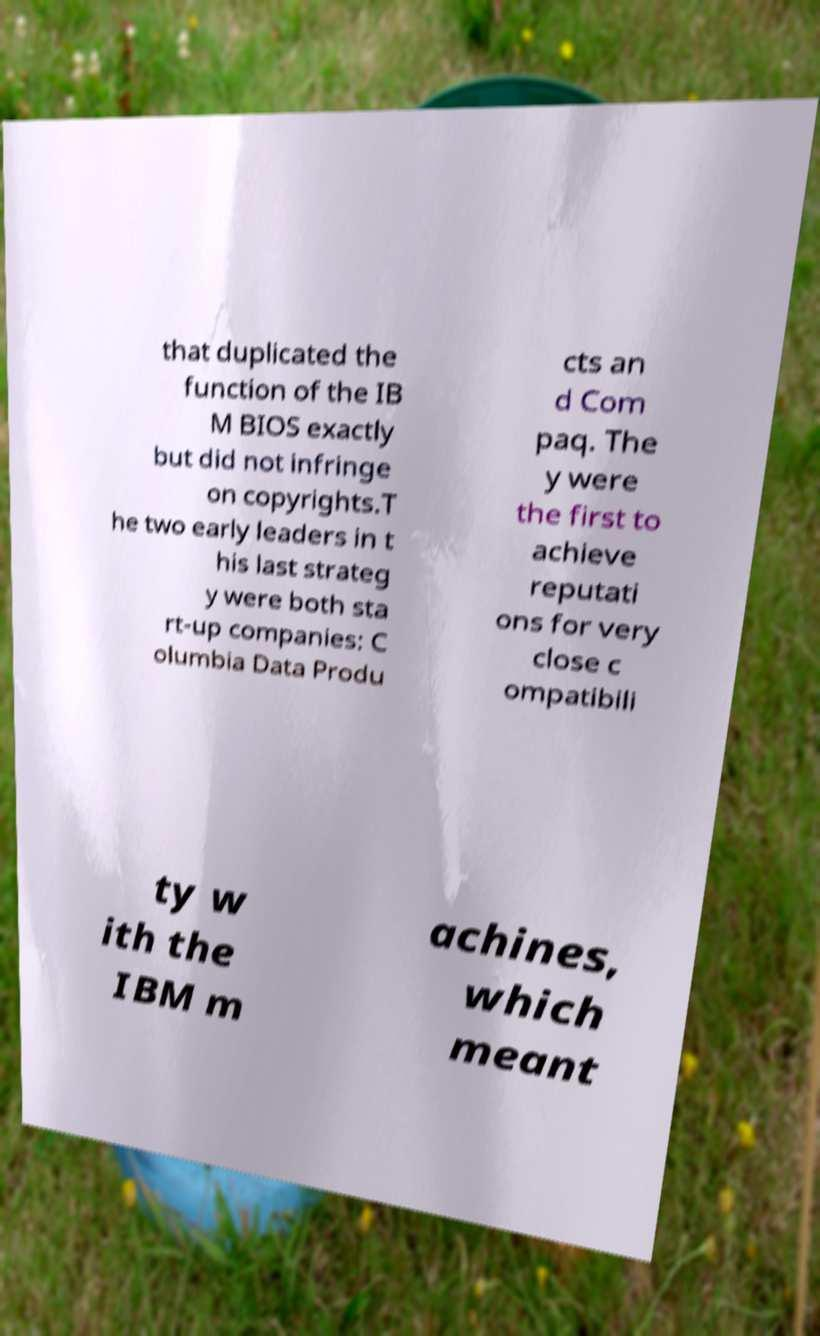What messages or text are displayed in this image? I need them in a readable, typed format. that duplicated the function of the IB M BIOS exactly but did not infringe on copyrights.T he two early leaders in t his last strateg y were both sta rt-up companies: C olumbia Data Produ cts an d Com paq. The y were the first to achieve reputati ons for very close c ompatibili ty w ith the IBM m achines, which meant 